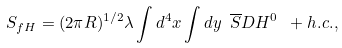Convert formula to latex. <formula><loc_0><loc_0><loc_500><loc_500>S _ { f H } = { ( 2 \pi R ) ^ { 1 / 2 } \lambda } \int d ^ { 4 } x \int d y \ \overline { S } D H ^ { 0 } \ + h . c . ,</formula> 